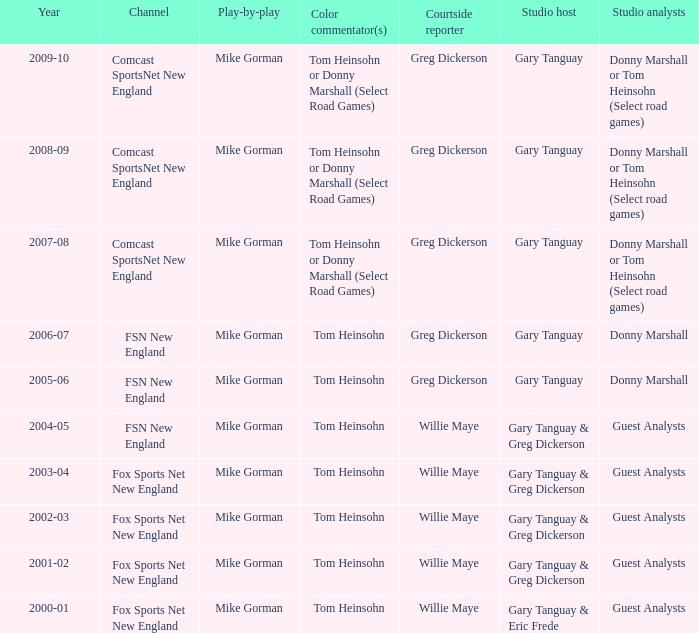WHich Studio analysts has a Studio host of gary tanguay in 2009-10? Donny Marshall or Tom Heinsohn (Select road games). 